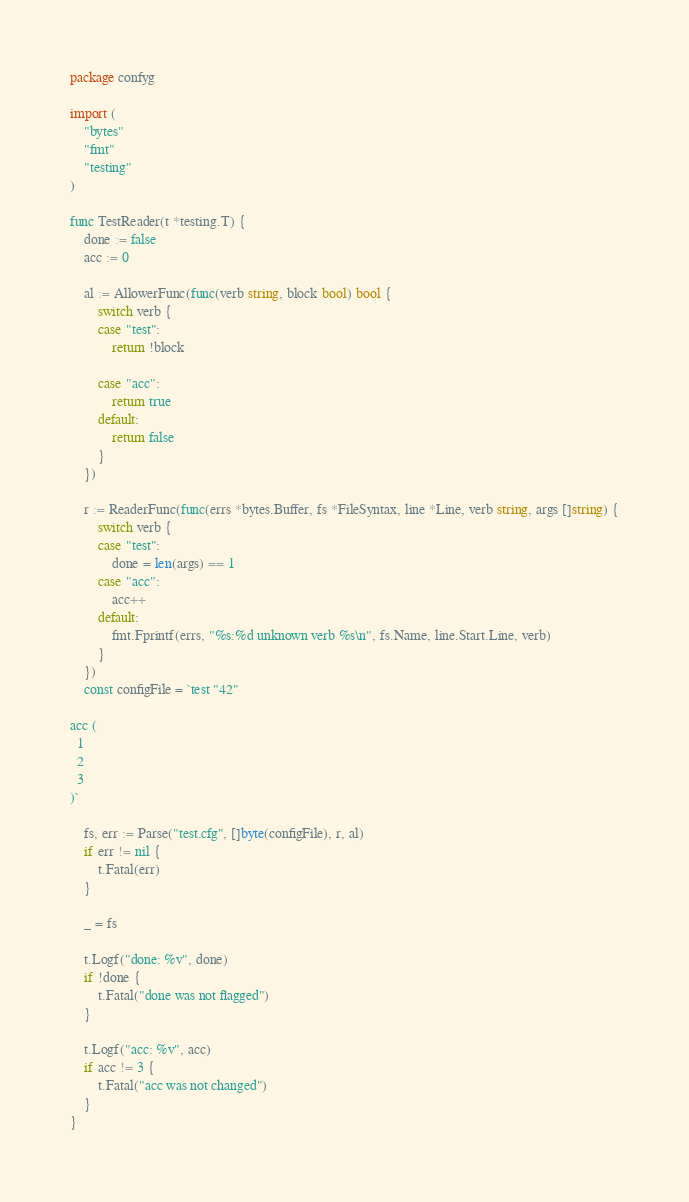Convert code to text. <code><loc_0><loc_0><loc_500><loc_500><_Go_>package confyg

import (
	"bytes"
	"fmt"
	"testing"
)

func TestReader(t *testing.T) {
	done := false
	acc := 0

	al := AllowerFunc(func(verb string, block bool) bool {
		switch verb {
		case "test":
			return !block

		case "acc":
			return true
		default:
			return false
		}
	})

	r := ReaderFunc(func(errs *bytes.Buffer, fs *FileSyntax, line *Line, verb string, args []string) {
		switch verb {
		case "test":
			done = len(args) == 1
		case "acc":
			acc++
		default:
			fmt.Fprintf(errs, "%s:%d unknown verb %s\n", fs.Name, line.Start.Line, verb)
		}
	})
	const configFile = `test "42"

acc (
  1
  2
  3
)`

	fs, err := Parse("test.cfg", []byte(configFile), r, al)
	if err != nil {
		t.Fatal(err)
	}

	_ = fs

	t.Logf("done: %v", done)
	if !done {
		t.Fatal("done was not flagged")
	}

	t.Logf("acc: %v", acc)
	if acc != 3 {
		t.Fatal("acc was not changed")
	}
}
</code> 